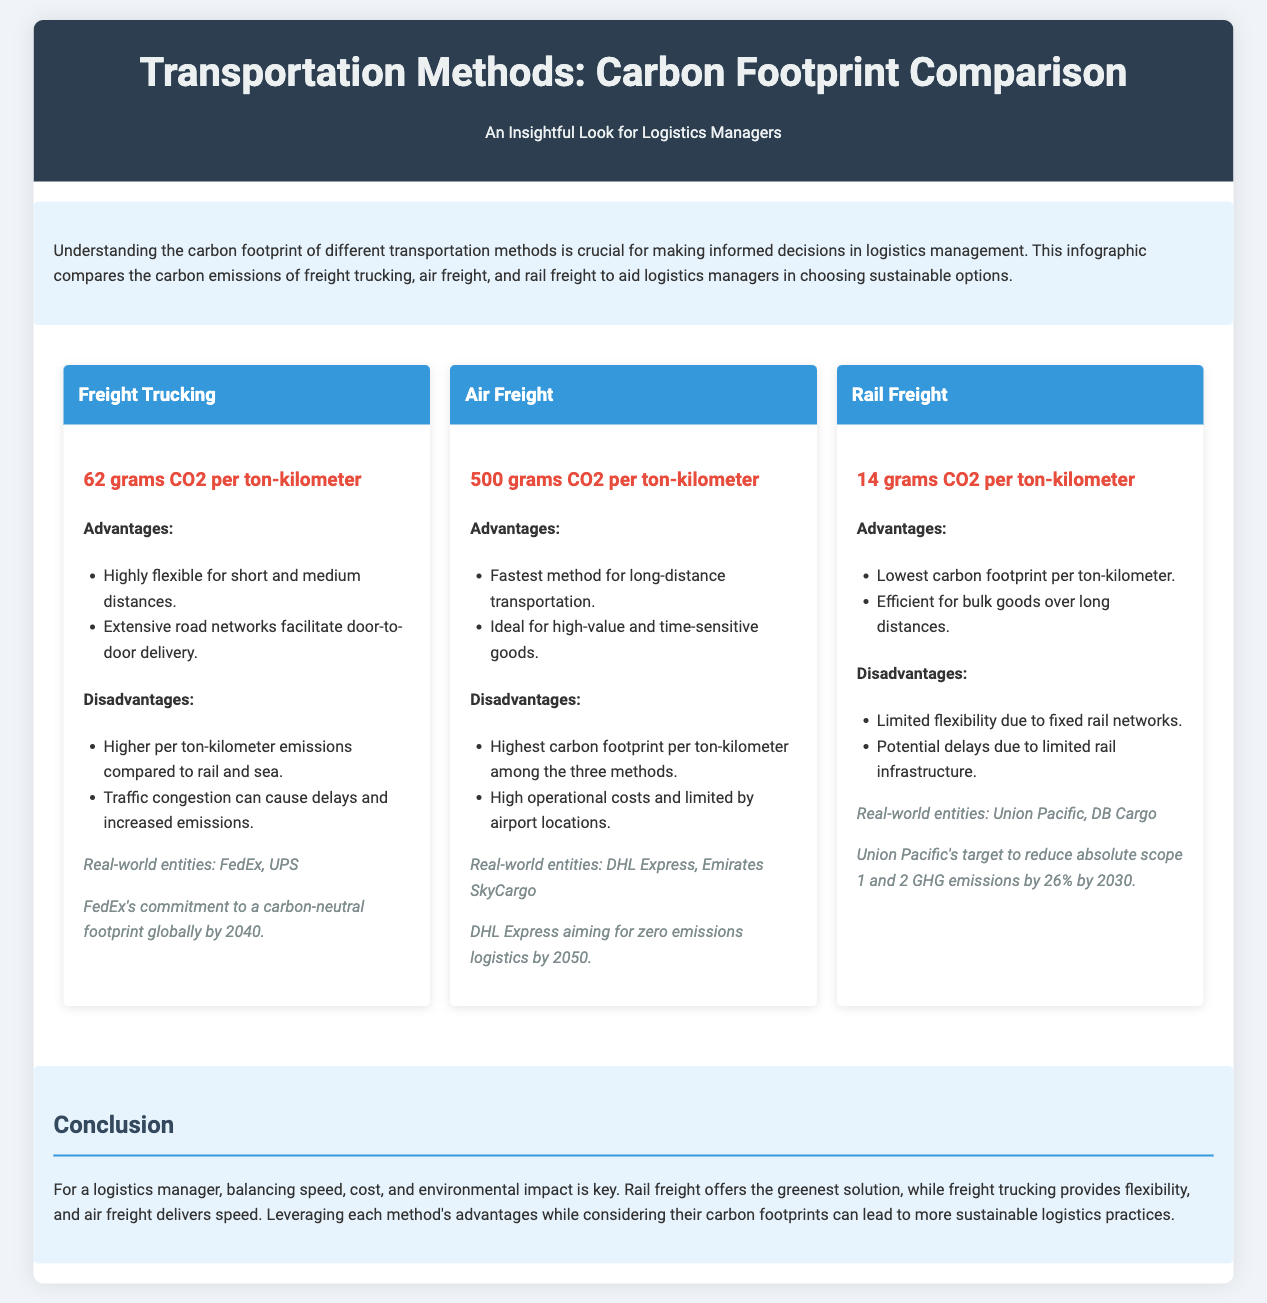what is the carbon footprint of freight trucking? The document states that freight trucking has a carbon footprint of 62 grams CO2 per ton-kilometer.
Answer: 62 grams CO2 per ton-kilometer what is the carbon footprint of air freight? According to the document, air freight emits 500 grams CO2 per ton-kilometer.
Answer: 500 grams CO2 per ton-kilometer which transportation method has the lowest carbon footprint? The comparison shows that rail freight has the lowest carbon footprint among the three methods, at 14 grams CO2 per ton-kilometer.
Answer: Rail freight which company has a commitment for a carbon-neutral footprint by 2040? The document mentions FedEx's commitment to a carbon-neutral footprint globally by 2040.
Answer: FedEx what is a disadvantage of rail freight? One disadvantage of rail freight mentioned is its limited flexibility due to fixed rail networks.
Answer: Limited flexibility due to fixed rail networks what kind of goods is air freight ideal for? The document indicates that air freight is ideal for high-value and time-sensitive goods.
Answer: High-value and time-sensitive goods what is a major advantage of freight trucking? The document states that a major advantage of freight trucking is its high flexibility for short and medium distances.
Answer: Highly flexible for short and medium distances what emission reduction target does Union Pacific have? According to the document, Union Pacific's target is to reduce absolute scope 1 and 2 GHG emissions by 26% by 2030.
Answer: 26% by 2030 